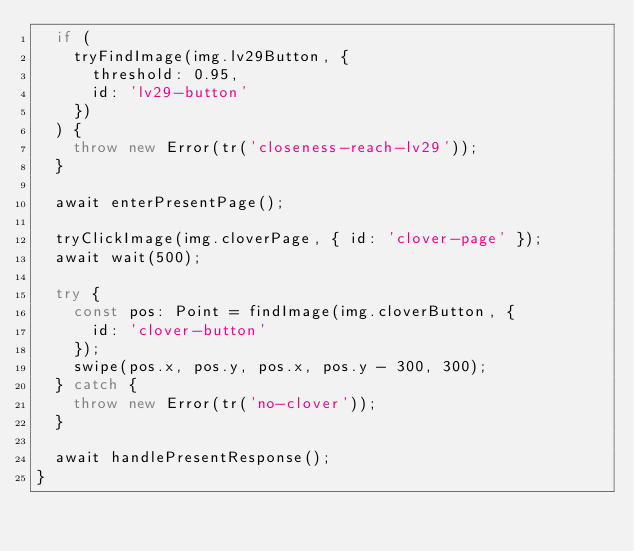Convert code to text. <code><loc_0><loc_0><loc_500><loc_500><_TypeScript_>  if (
    tryFindImage(img.lv29Button, {
      threshold: 0.95,
      id: 'lv29-button'
    })
  ) {
    throw new Error(tr('closeness-reach-lv29'));
  }

  await enterPresentPage();

  tryClickImage(img.cloverPage, { id: 'clover-page' });
  await wait(500);

  try {
    const pos: Point = findImage(img.cloverButton, {
      id: 'clover-button'
    });
    swipe(pos.x, pos.y, pos.x, pos.y - 300, 300);
  } catch {
    throw new Error(tr('no-clover'));
  }

  await handlePresentResponse();
}
</code> 